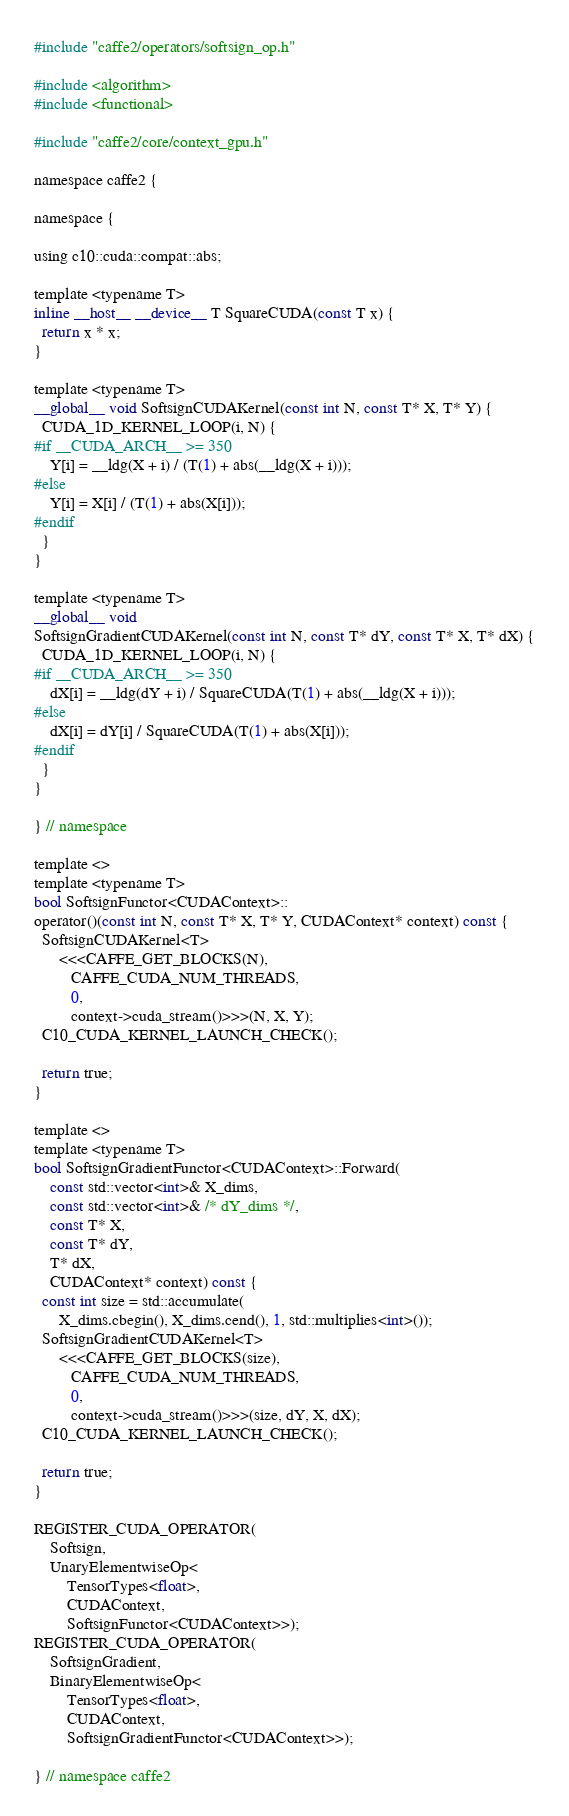<code> <loc_0><loc_0><loc_500><loc_500><_Cuda_>#include "caffe2/operators/softsign_op.h"

#include <algorithm>
#include <functional>

#include "caffe2/core/context_gpu.h"

namespace caffe2 {

namespace {

using c10::cuda::compat::abs;

template <typename T>
inline __host__ __device__ T SquareCUDA(const T x) {
  return x * x;
}

template <typename T>
__global__ void SoftsignCUDAKernel(const int N, const T* X, T* Y) {
  CUDA_1D_KERNEL_LOOP(i, N) {
#if __CUDA_ARCH__ >= 350
    Y[i] = __ldg(X + i) / (T(1) + abs(__ldg(X + i)));
#else
    Y[i] = X[i] / (T(1) + abs(X[i]));
#endif
  }
}

template <typename T>
__global__ void
SoftsignGradientCUDAKernel(const int N, const T* dY, const T* X, T* dX) {
  CUDA_1D_KERNEL_LOOP(i, N) {
#if __CUDA_ARCH__ >= 350
    dX[i] = __ldg(dY + i) / SquareCUDA(T(1) + abs(__ldg(X + i)));
#else
    dX[i] = dY[i] / SquareCUDA(T(1) + abs(X[i]));
#endif
  }
}

} // namespace

template <>
template <typename T>
bool SoftsignFunctor<CUDAContext>::
operator()(const int N, const T* X, T* Y, CUDAContext* context) const {
  SoftsignCUDAKernel<T>
      <<<CAFFE_GET_BLOCKS(N),
         CAFFE_CUDA_NUM_THREADS,
         0,
         context->cuda_stream()>>>(N, X, Y);
  C10_CUDA_KERNEL_LAUNCH_CHECK();

  return true;
}

template <>
template <typename T>
bool SoftsignGradientFunctor<CUDAContext>::Forward(
    const std::vector<int>& X_dims,
    const std::vector<int>& /* dY_dims */,
    const T* X,
    const T* dY,
    T* dX,
    CUDAContext* context) const {
  const int size = std::accumulate(
      X_dims.cbegin(), X_dims.cend(), 1, std::multiplies<int>());
  SoftsignGradientCUDAKernel<T>
      <<<CAFFE_GET_BLOCKS(size),
         CAFFE_CUDA_NUM_THREADS,
         0,
         context->cuda_stream()>>>(size, dY, X, dX);
  C10_CUDA_KERNEL_LAUNCH_CHECK();

  return true;
}

REGISTER_CUDA_OPERATOR(
    Softsign,
    UnaryElementwiseOp<
        TensorTypes<float>,
        CUDAContext,
        SoftsignFunctor<CUDAContext>>);
REGISTER_CUDA_OPERATOR(
    SoftsignGradient,
    BinaryElementwiseOp<
        TensorTypes<float>,
        CUDAContext,
        SoftsignGradientFunctor<CUDAContext>>);

} // namespace caffe2
</code> 